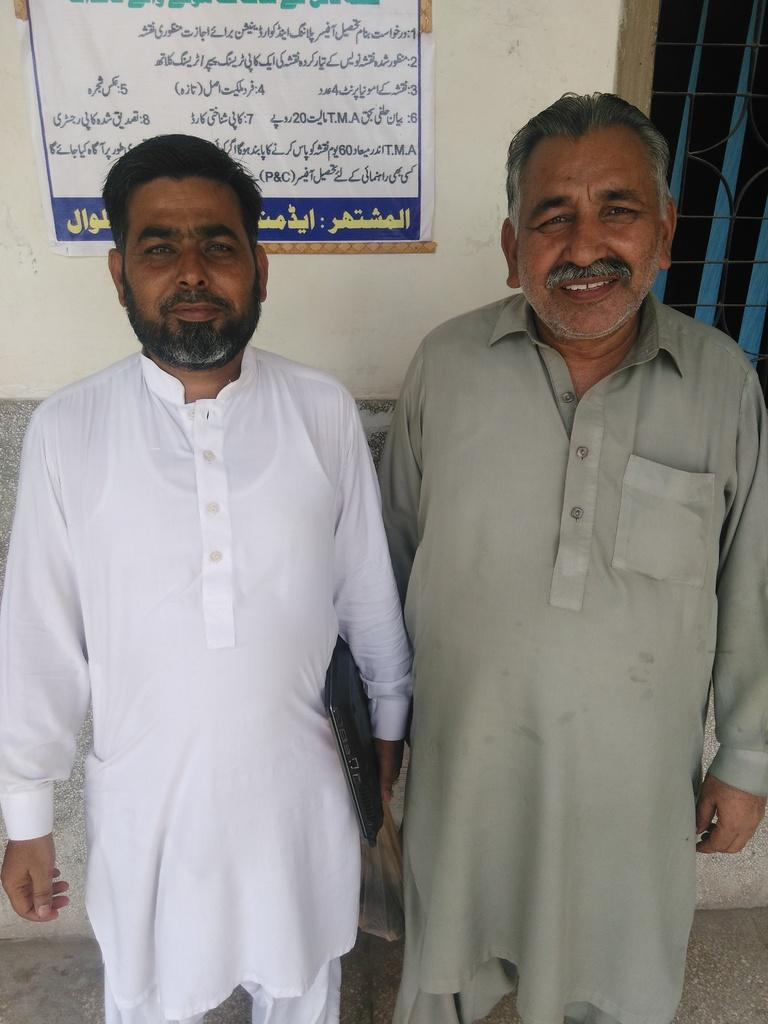How many people are in the image? There are two men in the image. What are the men doing in the image? The men are standing together in a room. What can be seen behind the men? There is a wall behind the men. What is on the wall behind the men? There is a banner on the wall. How many chairs are visible in the image? There are no chairs visible in the image. Can you purchase a ticket for the event depicted on the banner? The image does not provide information about purchasing tickets for any event. 